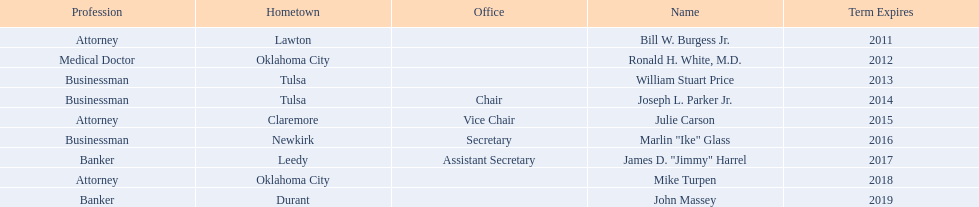Where is bill w. burgess jr. from? Lawton. Where is price and parker from? Tulsa. Who is from the same state as white? Mike Turpen. 